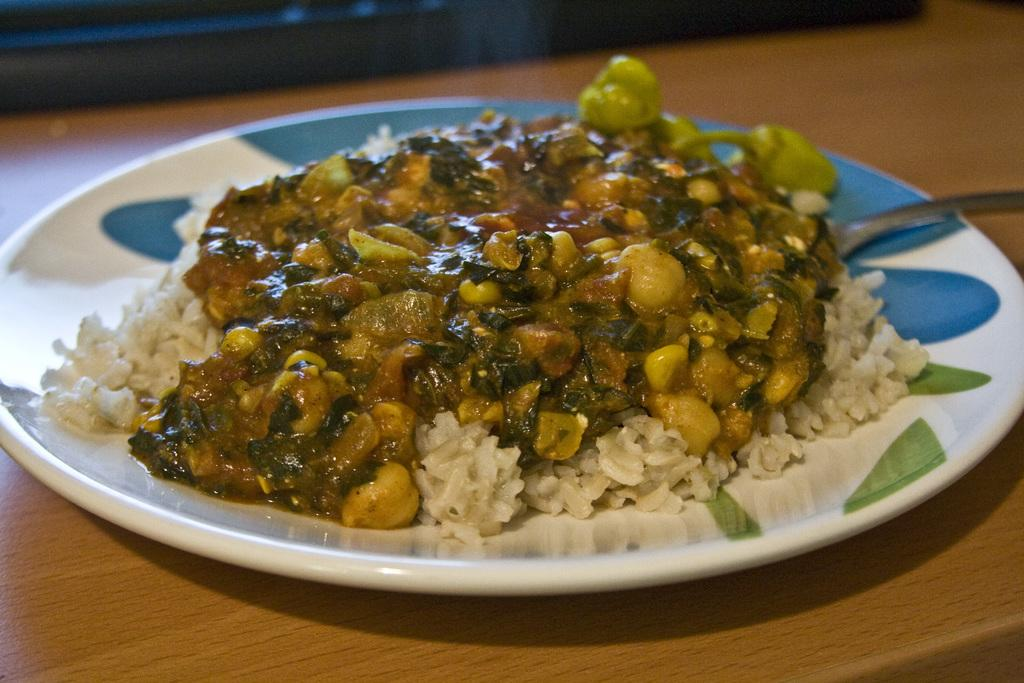What type of surface is visible in the image? There is a wooden surface in the image. What is placed on the wooden surface? There is a plate on the wooden surface. What can be found on the plate? There is a food item and a spoon on the plate. What type of authority figure is present in the image? There is no authority figure present in the image; it only features a wooden surface, a plate, a food item, and a spoon. 